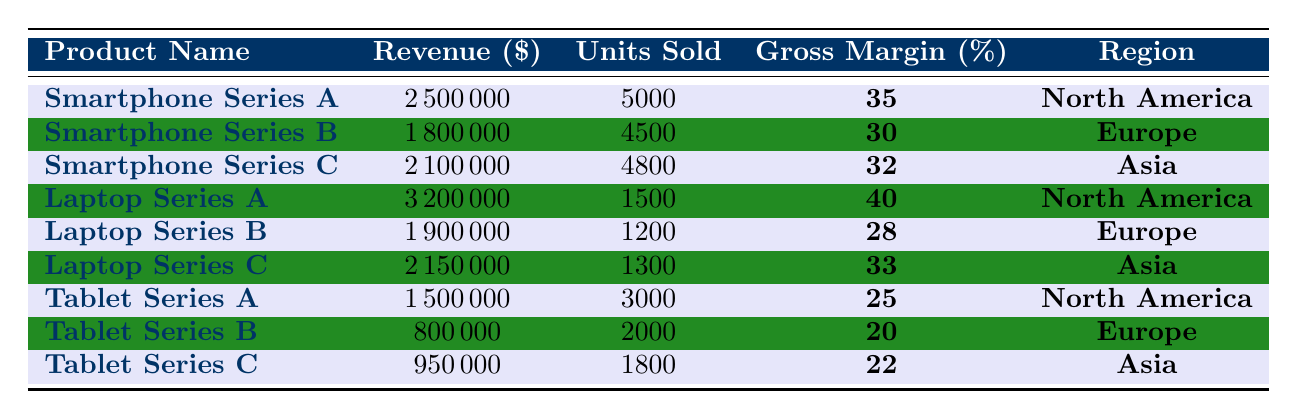What is the revenue of Laptop Series A? The revenue for Laptop Series A is directly provided in the table. It states that Laptop Series A has a revenue of 3,200,000 dollars.
Answer: 3,200,000 Which product line has the highest gross margin? To determine which product line has the highest gross margin, I compare the gross margin percentages from the table: Smartphone Series A (35%), Smartphone Series B (30%), Smartphone Series C (32%), Laptop Series A (40%), Laptop Series B (28%), Laptop Series C (33%), Tablet Series A (25%), Tablet Series B (20%), Tablet Series C (22%). The highest is 40% for Laptop Series A.
Answer: Laptop Series A What is the total revenue from Smartphone Series products? To calculate the total revenue from Smartphone Series products, I add the revenues of Smartphone Series A (2,500,000), Smartphone Series B (1,800,000), and Smartphone Series C (2,100,000): 2,500,000 + 1,800,000 + 2,100,000 = 6,400,000.
Answer: 6,400,000 Which region has the highest revenue among the product lines listed? I will compare the total revenues per region by summing the revenues for each product in North America, Europe, and Asia. For North America: 2,500,000 (Smartphone) + 3,200,000 (Laptop) + 1,500,000 (Tablet) = 7,200,000. For Europe: 1,800,000 (Smartphone) + 1,900,000 (Laptop) + 800,000 (Tablet) = 4,500,000. For Asia: 2,100,000 (Smartphone) + 2,150,000 (Laptop) + 950,000 (Tablet) = 5,200,000. North America has the highest total at 7,200,000.
Answer: North America What is the average revenue of all product lines? To find the average revenue, first, I sum the revenues of all product lines: 2,500,000 + 1,800,000 + 2,100,000 + 3,200,000 + 1,900,000 + 2,150,000 + 1,500,000 + 800,000 + 950,000 = 18,950,000. There are 9 product lines, so the average revenue is 18,950,000 ÷ 9 = 2,105,555.56 (rounded).
Answer: 2,105,556 Is the revenue from Tablet Series A greater than the revenue from Tablet Series B? The revenue for Tablet Series A is 1,500,000 and for Tablet Series B is 800,000. Since 1,500,000 is greater than 800,000, the statement is true.
Answer: Yes Which product line sold the most units in Q3 2023? Looking at the units sold for all product lines: Smartphone Series A (5,000), Smartphone Series B (4,500), Smartphone Series C (4,800), Laptop Series A (1,500), Laptop Series B (1,200), Laptop Series C (1,300), Tablet Series A (3,000), Tablet Series B (2,000), and Tablet Series C (1,800). The highest number of units sold is 5,000 for Smartphone Series A.
Answer: Smartphone Series A What is the difference in revenue between Laptop Series A and Laptop Series B? To find the difference in revenue between Laptop Series A (3,200,000) and Laptop Series B (1,900,000), I subtract Laptop Series B revenue from Laptop Series A revenue: 3,200,000 - 1,900,000 = 1,300,000.
Answer: 1,300,000 How many total units were sold across all product lines? I will sum the units sold across all product lines: 5,000 + 4,500 + 4,800 + 1,500 + 1,200 + 1,300 + 3,000 + 2,000 + 1,800 = 25,100 units.
Answer: 25,100 Which product line has the lowest revenue? I will examine the revenue for each product line: Smartphone Series A (2,500,000), Smartphone Series B (1,800,000), Smartphone Series C (2,100,000), Laptop Series A (3,200,000), Laptop Series B (1,900,000), Laptop Series C (2,150,000), Tablet Series A (1,500,000), Tablet Series B (800,000), Tablet Series C (950,000). The lowest revenue is 800,000 for Tablet Series B.
Answer: Tablet Series B 